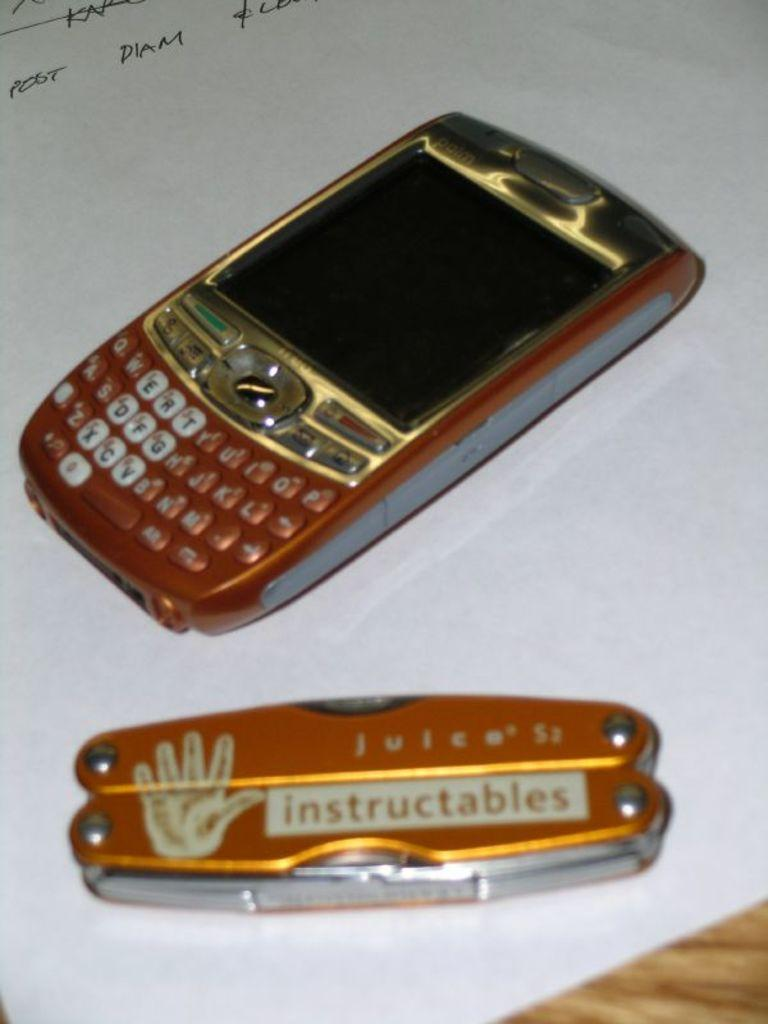<image>
Offer a succinct explanation of the picture presented. A gold multi tool with the word instructables sits on a piece of paper. 